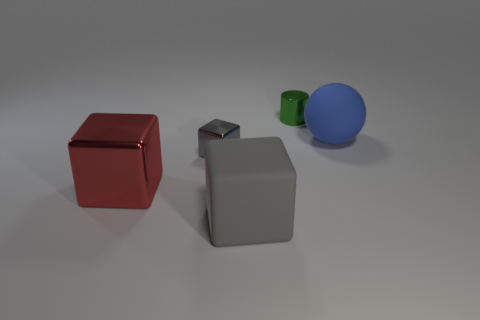There is a rubber block; does it have the same color as the tiny shiny thing that is in front of the large blue thing?
Make the answer very short. Yes. There is another block that is the same color as the large matte cube; what is its material?
Your response must be concise. Metal. What material is the cube that is to the left of the gray block that is behind the large matte object to the left of the blue ball?
Make the answer very short. Metal. The gray block that is on the right side of the tiny object that is left of the gray rubber thing is made of what material?
Your answer should be compact. Rubber. Is the number of large metal things right of the small green thing less than the number of big brown rubber things?
Provide a short and direct response. No. There is a large matte thing in front of the red object; what shape is it?
Provide a short and direct response. Cube. There is a ball; is its size the same as the object behind the blue ball?
Provide a succinct answer. No. Is there a green object that has the same material as the red cube?
Your answer should be very brief. Yes. What number of balls are large red things or large gray rubber things?
Offer a very short reply. 0. Are there any big rubber cubes that are behind the red object that is on the left side of the green metal cylinder?
Provide a short and direct response. No. 